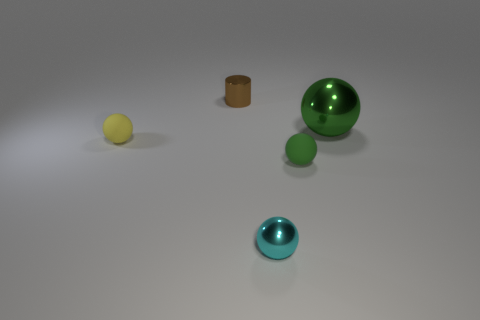Do the large metallic object and the rubber thing that is in front of the yellow matte object have the same color?
Keep it short and to the point. Yes. What is the size of the cyan object that is the same shape as the green rubber thing?
Provide a short and direct response. Small. Is the tiny cylinder the same color as the large sphere?
Your answer should be very brief. No. What number of other objects are the same material as the tiny yellow ball?
Provide a short and direct response. 1. Is the number of cyan metal things that are to the right of the yellow matte sphere the same as the number of tiny cyan objects?
Give a very brief answer. Yes. There is a thing in front of the green rubber object; does it have the same size as the big green metal object?
Offer a very short reply. No. There is a brown metallic cylinder; what number of large green metallic balls are behind it?
Your answer should be very brief. 0. There is a thing that is both behind the tiny yellow thing and on the right side of the cyan thing; what material is it?
Keep it short and to the point. Metal. How many tiny objects are either yellow cylinders or brown cylinders?
Make the answer very short. 1. The brown thing has what size?
Your answer should be compact. Small. 